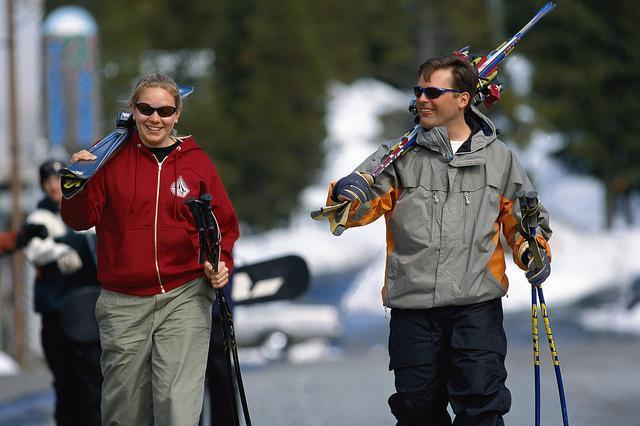How many people are in the picture?
Give a very brief answer. 3. How many snowboards are there?
Give a very brief answer. 1. 